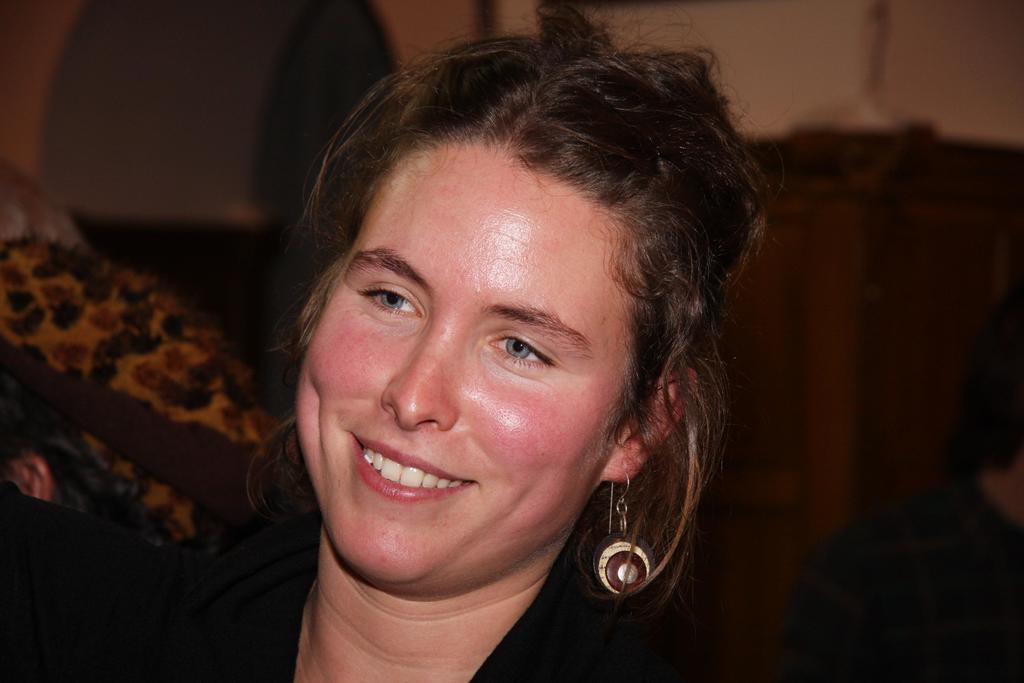Who is present in the image? There is a woman in the image. What is the woman doing in the image? The woman is smiling in the image. What is the woman wearing in the image? The woman is wearing a black dress in the image. What can be observed about the background of the image? The background of the woman is blurred in the image. What type of cake is the woman eating in the image? There is no cake present in the image; the woman is simply smiling. How does the woman's digestion appear to be affected by the food she is eating in the image? There is no indication of the woman eating any food in the image, so it's not possible to determine how her digestion might be affected. 